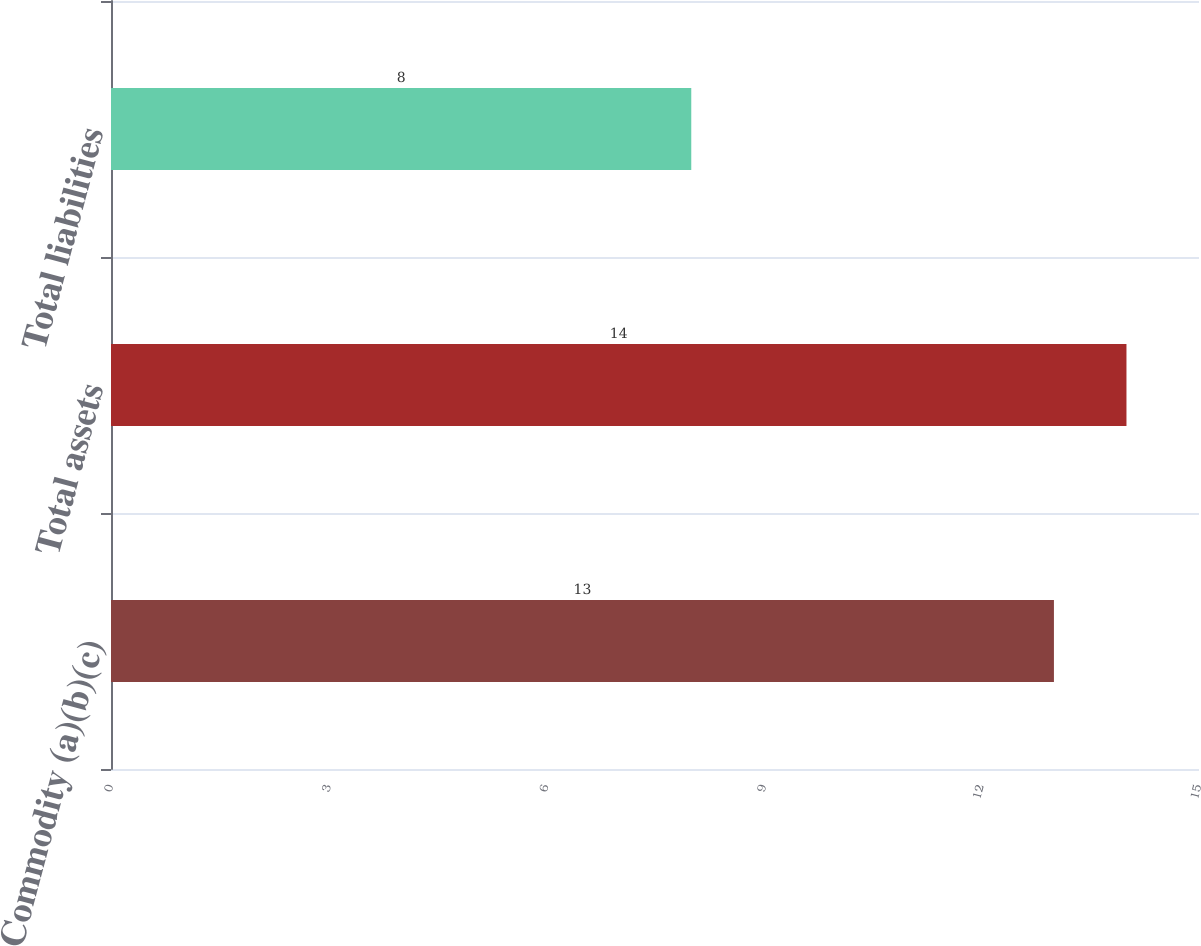Convert chart. <chart><loc_0><loc_0><loc_500><loc_500><bar_chart><fcel>Commodity (a)(b)(c)<fcel>Total assets<fcel>Total liabilities<nl><fcel>13<fcel>14<fcel>8<nl></chart> 